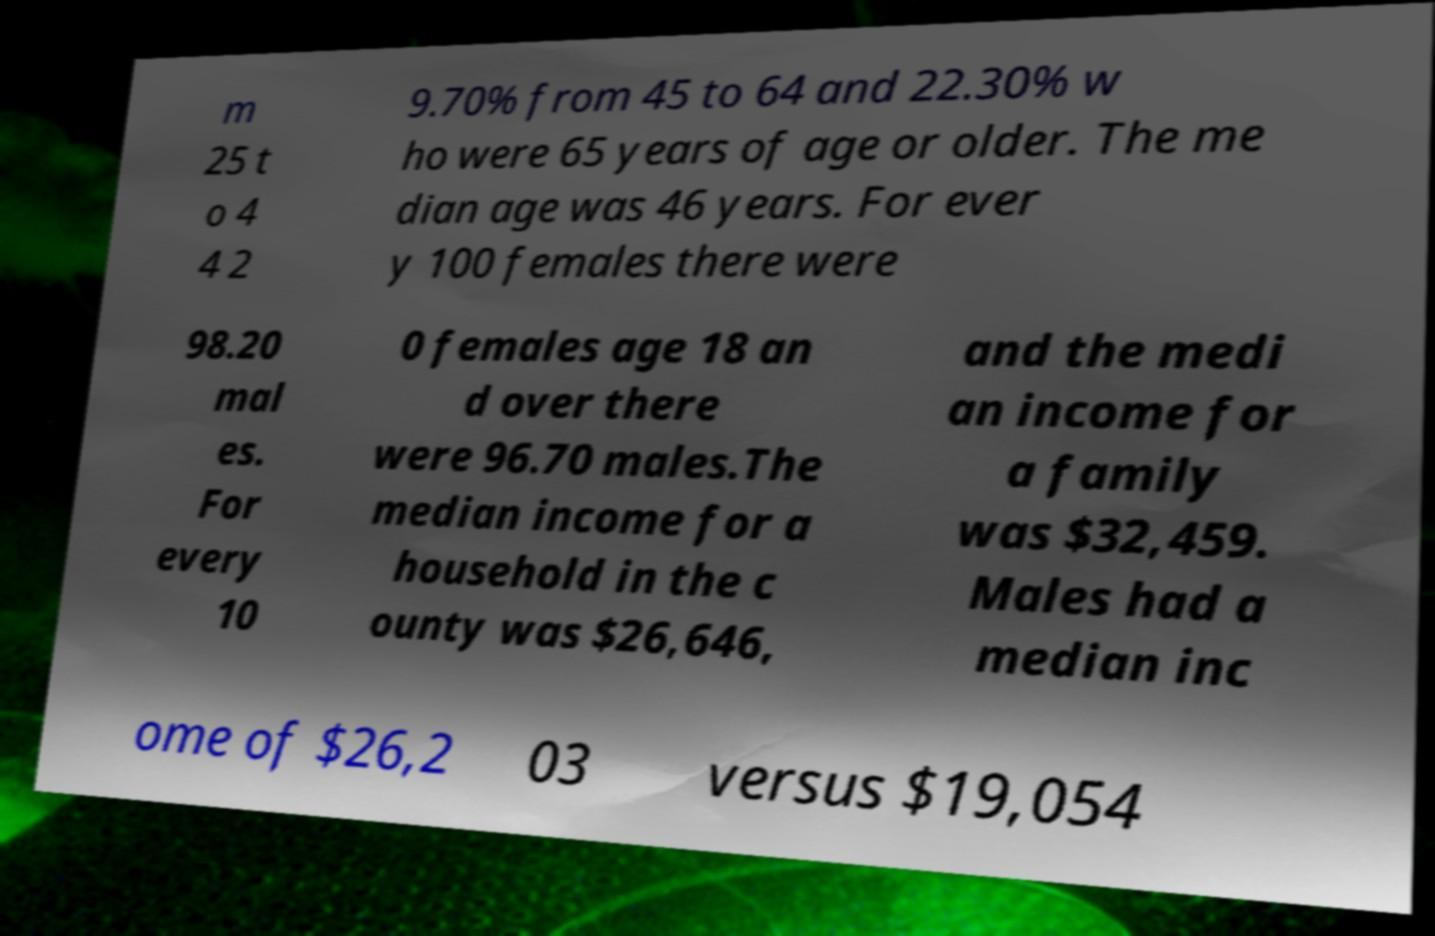For documentation purposes, I need the text within this image transcribed. Could you provide that? m 25 t o 4 4 2 9.70% from 45 to 64 and 22.30% w ho were 65 years of age or older. The me dian age was 46 years. For ever y 100 females there were 98.20 mal es. For every 10 0 females age 18 an d over there were 96.70 males.The median income for a household in the c ounty was $26,646, and the medi an income for a family was $32,459. Males had a median inc ome of $26,2 03 versus $19,054 